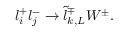<formula> <loc_0><loc_0><loc_500><loc_500>l _ { i } ^ { + } l _ { j } ^ { - } \rightarrow \tilde { l } _ { k , L } ^ { \mp } W ^ { \pm } .</formula> 